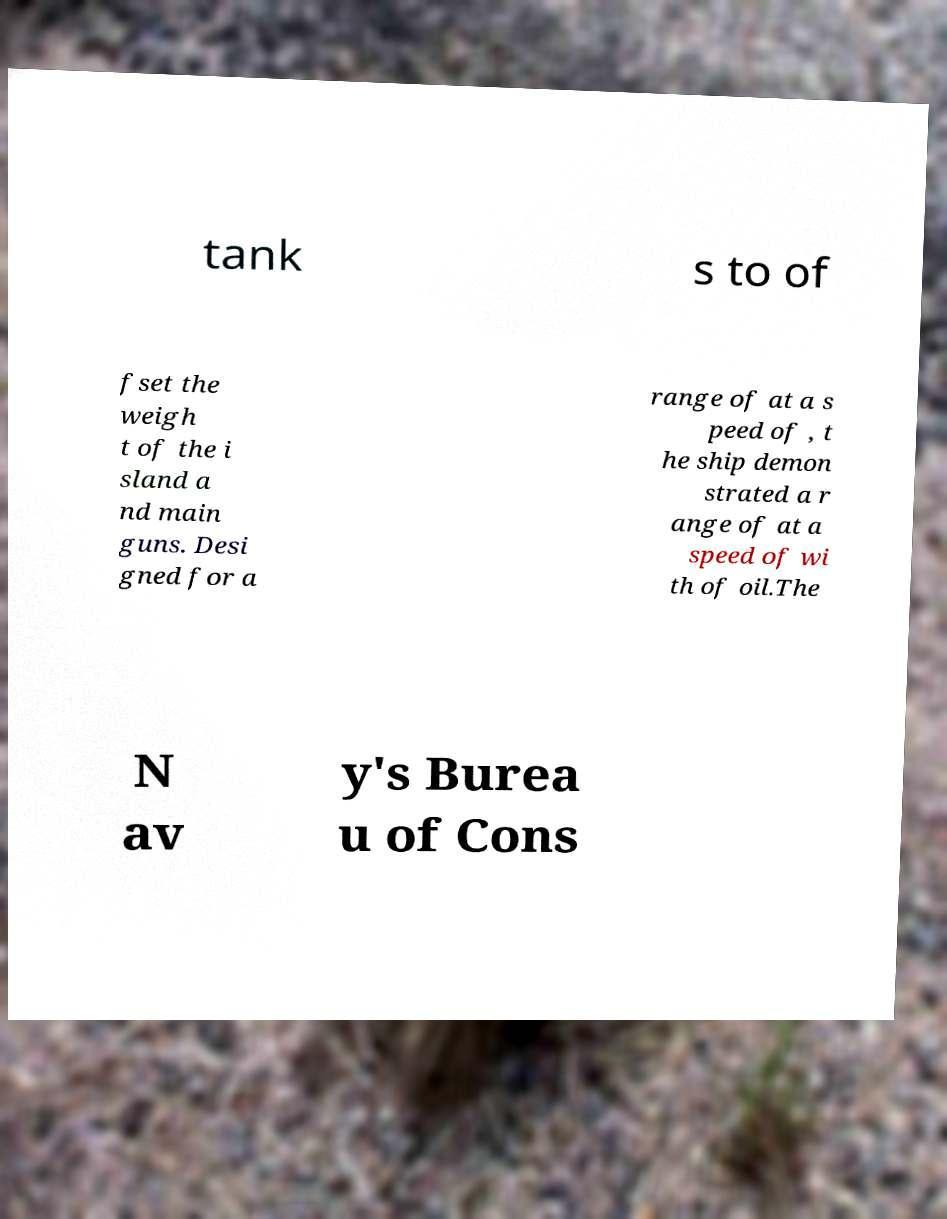Can you accurately transcribe the text from the provided image for me? tank s to of fset the weigh t of the i sland a nd main guns. Desi gned for a range of at a s peed of , t he ship demon strated a r ange of at a speed of wi th of oil.The N av y's Burea u of Cons 